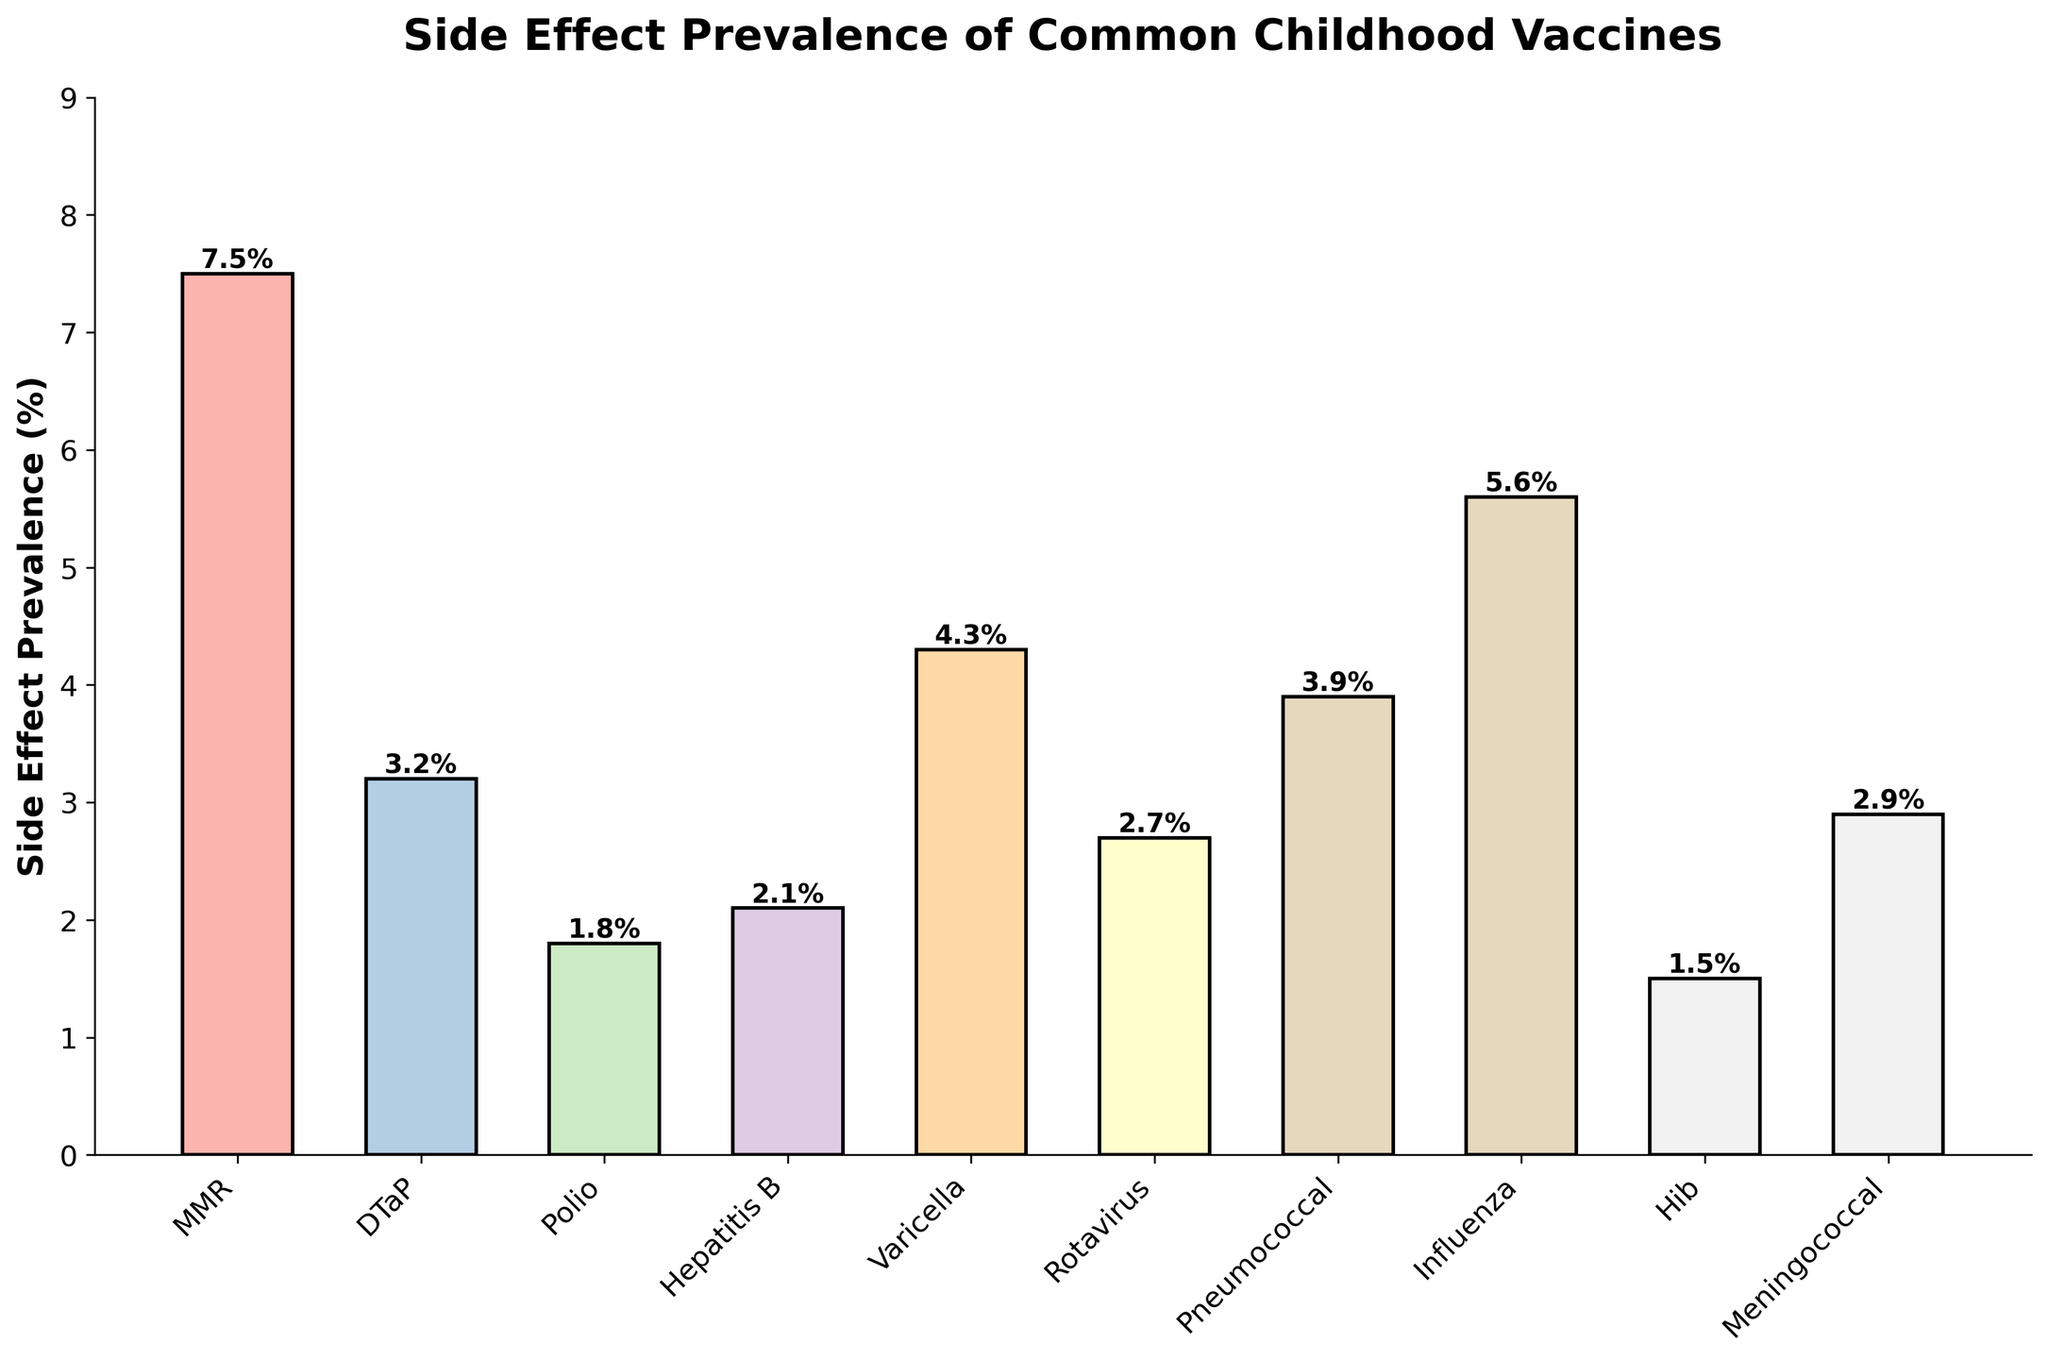Which vaccine has the highest side effect prevalence? By looking at the height of the bars, we can see that the MMR vaccine has the highest bar, indicating the highest side effect prevalence.
Answer: MMR Which vaccine has the lowest side effect prevalence? By comparing the heights of all the bars, we see that the Hib vaccine has the shortest bar, indicating the lowest side effect prevalence.
Answer: Hib What is the difference in side effect prevalence between the MMR and Hepatitis B vaccines? The MMR vaccine prevalence is 7.5%, and the Hepatitis B vaccine prevalence is 2.1%. The difference is 7.5% - 2.1% = 5.4%.
Answer: 5.4% What is the average side effect prevalence of the vaccines? To find the average, sum all prevalence values and divide by the number of vaccines: (7.5 + 3.2 + 1.8 + 2.1 + 4.3 + 2.7 + 3.9 + 5.6 + 1.5 + 2.9) / 10 = 3.55%.
Answer: 3.55% Is the side effect prevalence of the Influenza vaccine higher or lower than the Rotavirus vaccine? The Influenza vaccine has a prevalence of 5.6%, while the Rotavirus vaccine has a prevalence of 2.7%. Therefore, the Influenza vaccine's prevalence is higher.
Answer: Higher Two vaccines have a side effect prevalence above 5%. Identify them. The vaccines with prevalence values above 5% are the MMR (7.5%) and Influenza (5.6%) vaccines.
Answer: MMR and Influenza What is the combined side effect prevalence of the Meningococcal and Pneumococcal vaccines? The Meningococcal vaccine prevalence is 2.9%, and the Pneumococcal vaccine prevalence is 3.9%. The combined prevalence is 2.9% + 3.9% = 6.8%.
Answer: 6.8% Which vaccine shows a side effect prevalence closest to 3%? Comparing all the prevalence values, the Meningococcal vaccine with a prevalence of 2.9% is closest to 3%.
Answer: Meningococcal How many vaccines have a side effect prevalence below 3%? Counting the bars with prevalence below 3%: DTaP (3.2%), Polio (1.8%), Hepatitis B (2.1%), Rotavirus (2.7%), Hib (1.5%), Meningococcal (2.9%). There are 5 vaccines with prevalence below 3%.
Answer: 5 